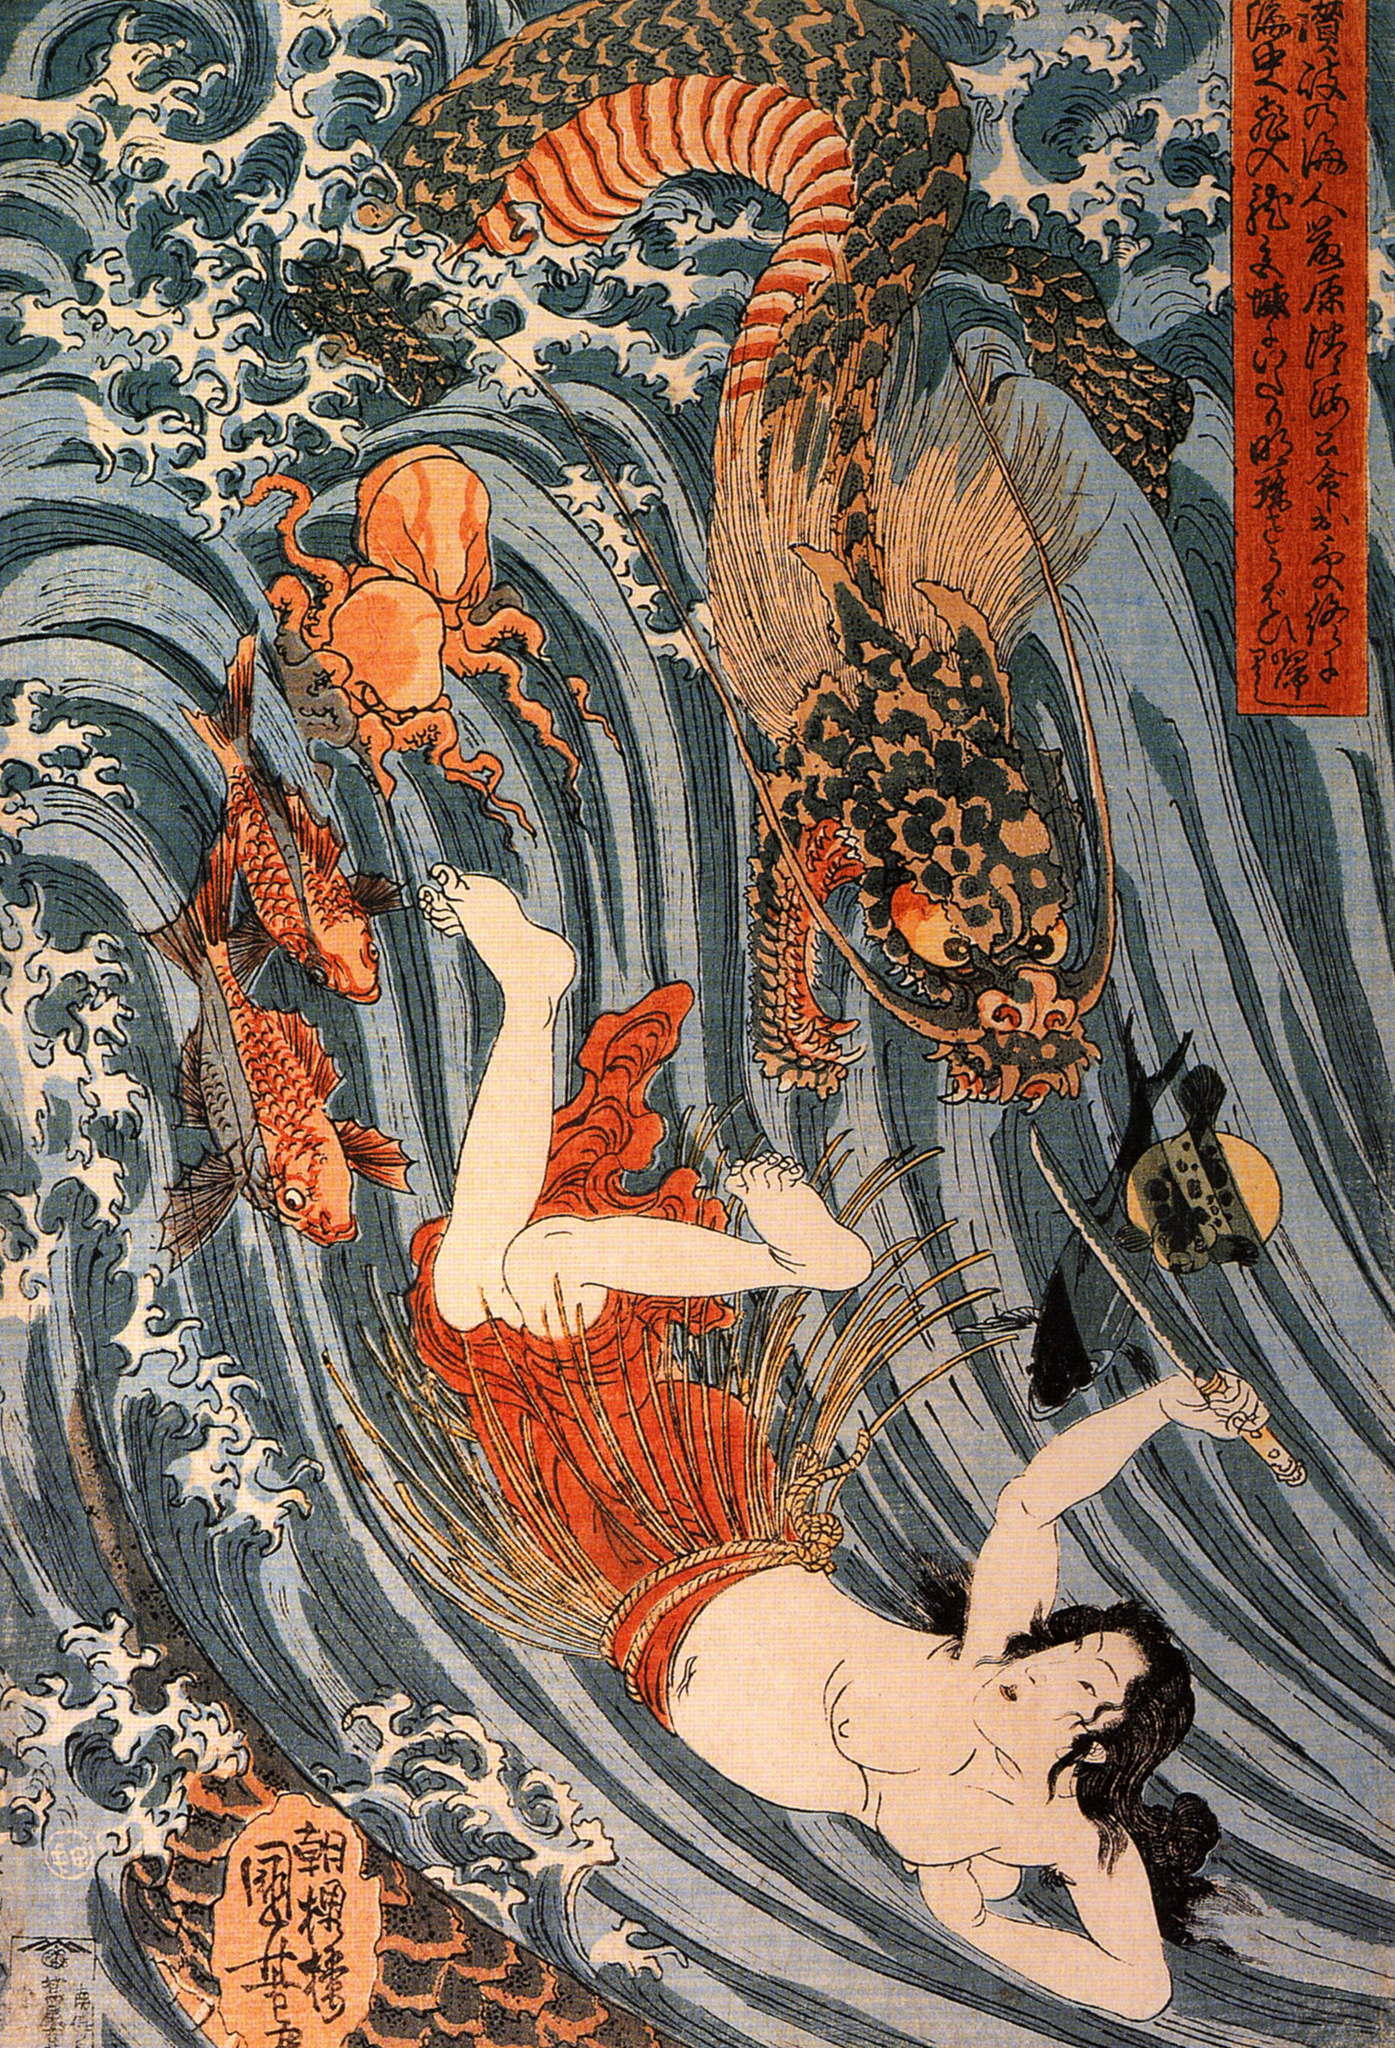What's happening in the scene? This image is a striking portrayal of a mythical encounter in the ukiyo-e style of Japanese woodblock print. Featuring a dramatic scene, the central narrative revolves around a bold, multifaceted dragon, adorned in orange and black scales, engaging dynamically with a woman in a vibrantly red and white outfit. She wields a fan, possibly denoting her role or status, amidst turbulent waves that lend a sense of motion to the piece. The use of vivacious colors and intricate patterns not only depicts a narrative scene but also conveys the cultural richness and storytelling traditionally associated with Japanese art. The artwork, titled in kanji, suggests themes of celestial or mythological importance, inviting interpretations of divine intervention or human interaction with the supernatural. 